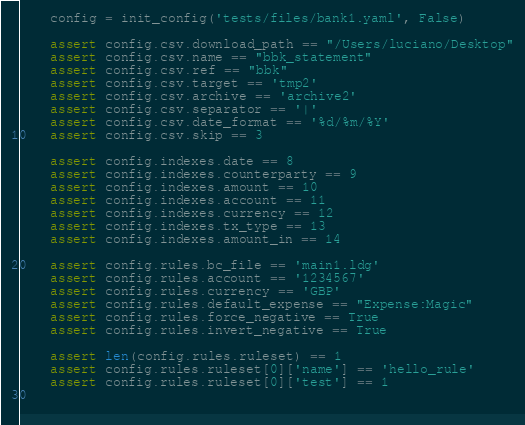<code> <loc_0><loc_0><loc_500><loc_500><_Python_>
    config = init_config('tests/files/bank1.yaml', False)

    assert config.csv.download_path == "/Users/luciano/Desktop"
    assert config.csv.name == "bbk_statement"
    assert config.csv.ref == "bbk"
    assert config.csv.target == 'tmp2'
    assert config.csv.archive == 'archive2'
    assert config.csv.separator == '|'
    assert config.csv.date_format == '%d/%m/%Y'
    assert config.csv.skip == 3

    assert config.indexes.date == 8
    assert config.indexes.counterparty == 9
    assert config.indexes.amount == 10
    assert config.indexes.account == 11
    assert config.indexes.currency == 12
    assert config.indexes.tx_type == 13
    assert config.indexes.amount_in == 14

    assert config.rules.bc_file == 'main1.ldg'
    assert config.rules.account == '1234567'
    assert config.rules.currency == 'GBP'
    assert config.rules.default_expense == "Expense:Magic"
    assert config.rules.force_negative == True
    assert config.rules.invert_negative == True

    assert len(config.rules.ruleset) == 1
    assert config.rules.ruleset[0]['name'] == 'hello_rule'
    assert config.rules.ruleset[0]['test'] == 1
    
    </code> 